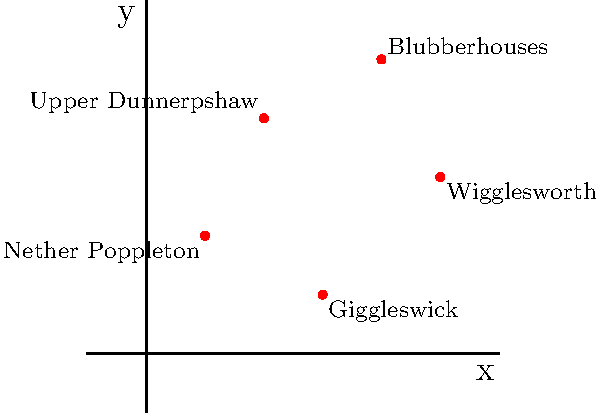Five quirky Yorkshire towns have been plotted on a coordinate grid based on their relative locations. The towns are Nether Poppleton, Upper Dunnerpshaw, Giggleswick, Blubberhouses, and Wigglesworth. If you were to draw a line connecting these towns in the order they are listed, what would be the total distance traveled? Round your answer to the nearest whole number. To solve this problem, we need to calculate the distance between consecutive points and sum them up. We'll use the distance formula: $d = \sqrt{(x_2-x_1)^2 + (y_2-y_1)^2}$

1. Distance from Nether Poppleton (1,2) to Upper Dunnerpshaw (2,4):
   $d_1 = \sqrt{(2-1)^2 + (4-2)^2} = \sqrt{1 + 4} = \sqrt{5} \approx 2.24$

2. Distance from Upper Dunnerpshaw (2,4) to Giggleswick (3,1):
   $d_2 = \sqrt{(3-2)^2 + (1-4)^2} = \sqrt{1 + 9} = \sqrt{10} \approx 3.16$

3. Distance from Giggleswick (3,1) to Blubberhouses (4,5):
   $d_3 = \sqrt{(4-3)^2 + (5-1)^2} = \sqrt{1 + 16} = \sqrt{17} \approx 4.12$

4. Distance from Blubberhouses (4,5) to Wigglesworth (5,3):
   $d_4 = \sqrt{(5-4)^2 + (3-5)^2} = \sqrt{1 + 4} = \sqrt{5} \approx 2.24$

Total distance: $d_{total} = d_1 + d_2 + d_3 + d_4 \approx 2.24 + 3.16 + 4.12 + 2.24 = 11.76$

Rounding to the nearest whole number: 12
Answer: 12 